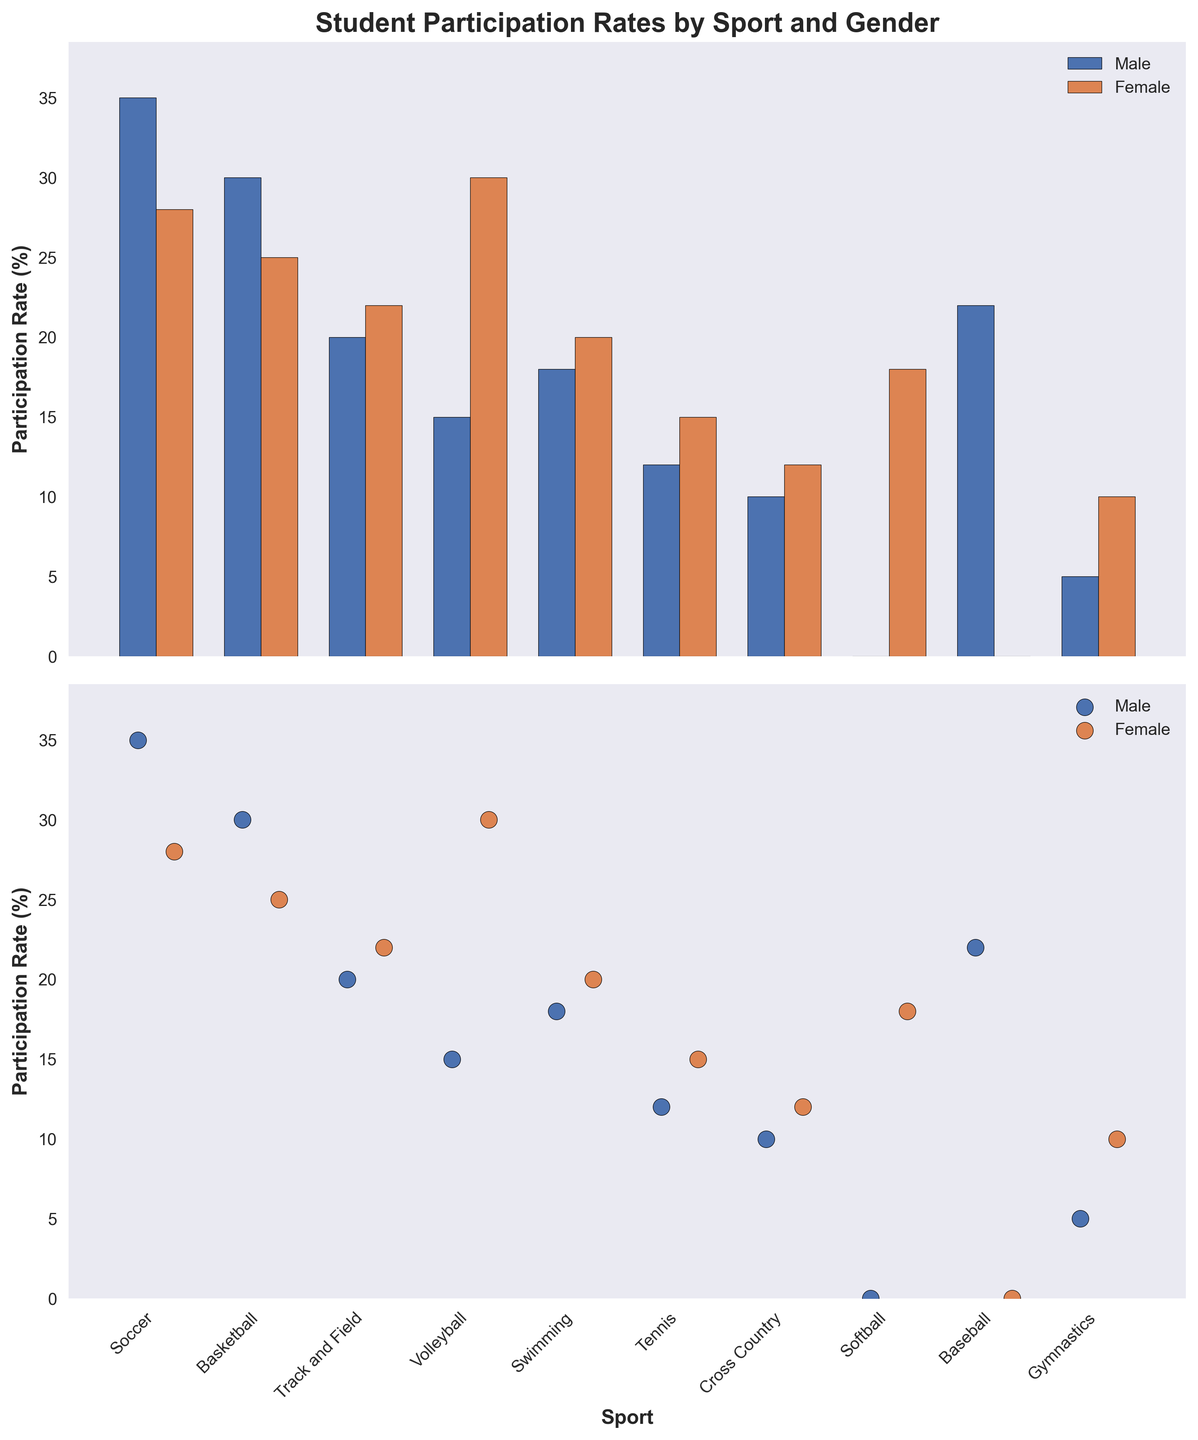What is the title of the figure? The title is usually located at the top of the plot. Here, it is clearly labeled at the top of the figure.
Answer: Student Participation Rates by Sport and Gender What are the colors used to represent male and female participation rates in the bar chart? The colors of the bars are noted in the legend. 'Male' is represented by blue, and 'Female' is represented by orange.
Answer: Blue and orange Which sport has the highest female participation rate? Look for the tallest orange-colored bar or highest orange dot in the second subplot. Volleyball has the tallest orange bar.
Answer: Volleyball What is the difference in participation rates between males and females in Basketball? Identify the heights of the bars for males and females in Basketball and subtract. Males have 30 and females have 25, so the difference is 30 - 25.
Answer: 5 Which sports have zero participation rates for males and females, respectively? Look for bars that have zero height for each gender separately. Softball has zero males, and Baseball has zero females.
Answer: Softball (males), Baseball (females) What is the average participation rate for males across all sports? Sum the heights (participation rates) of all male bars and divide by the number of sports. The total is 35+30+20+15+18+12+10+0+22+5 = 167, and there are 10 sports.
Answer: 16.7 Overall, do males or females participate more in Tennis, and by how much? Compare the heights (participation rates) of the bars for Tennis. Males have 12, and females have 15, so females participate more by 15 - 12.
Answer: Females by 3 What is the median participation rate for females across all sports? List all the female rates in order: 10, 12, 15, 18, 20, 22, 25, 28, 30, and find the middle value(s). Here, (20+22)/2 = 21.
Answer: 21 How many sports have higher participation rates for females than males? Count the instances where the orange bar is taller than the blue bar. This occurs in Track and Field, Volleyball, Swimming, Tennis, Softball, and Gymnastics.
Answer: 6 For which sport is the participation rate equal between males and females? Look for bars that have the same height for both genders. Here, it is not seen for any sport in the figure provided.
Answer: None 